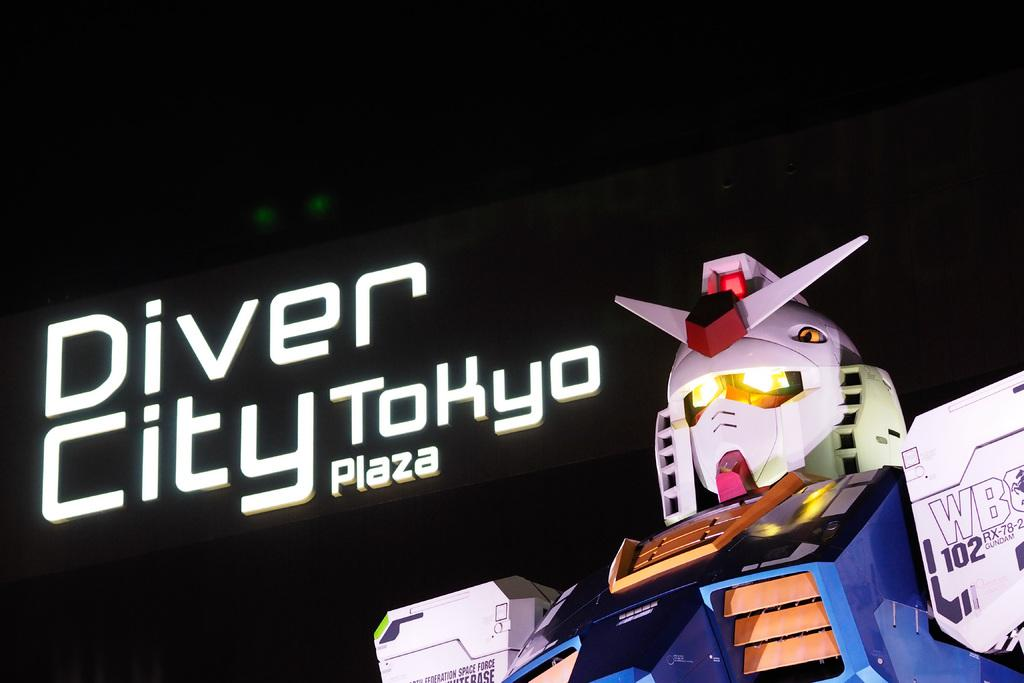What is the main subject of the image? The main subject of the image is a robot. What else can be seen in the image besides the robot? There is text in the image. Can you describe the background of the image? The background of the image is dark. How many stars can be seen in the image? There are no stars visible in the image; the background is dark. What type of event is the robot attending in the image? There is no indication of an event in the image; it simply features a robot and text. 